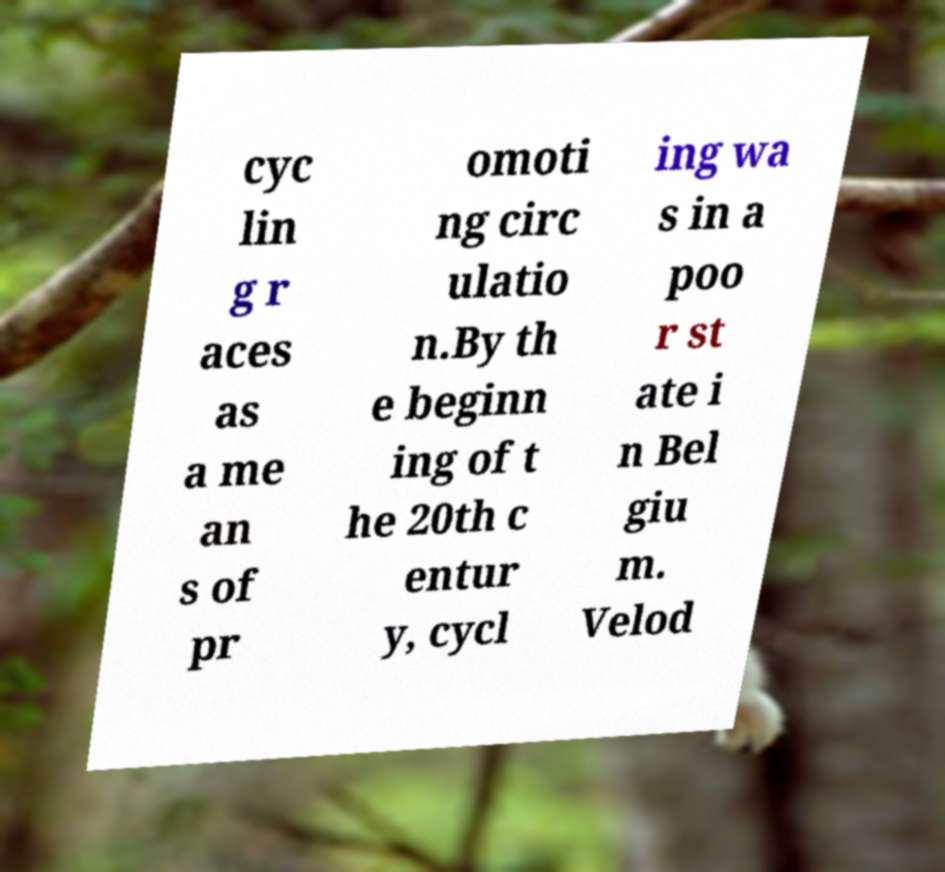I need the written content from this picture converted into text. Can you do that? cyc lin g r aces as a me an s of pr omoti ng circ ulatio n.By th e beginn ing of t he 20th c entur y, cycl ing wa s in a poo r st ate i n Bel giu m. Velod 